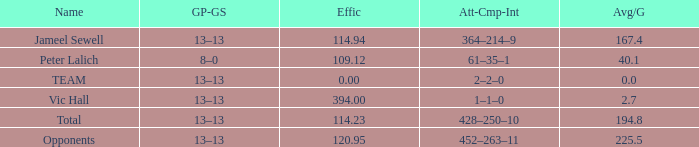7? 394.0. 